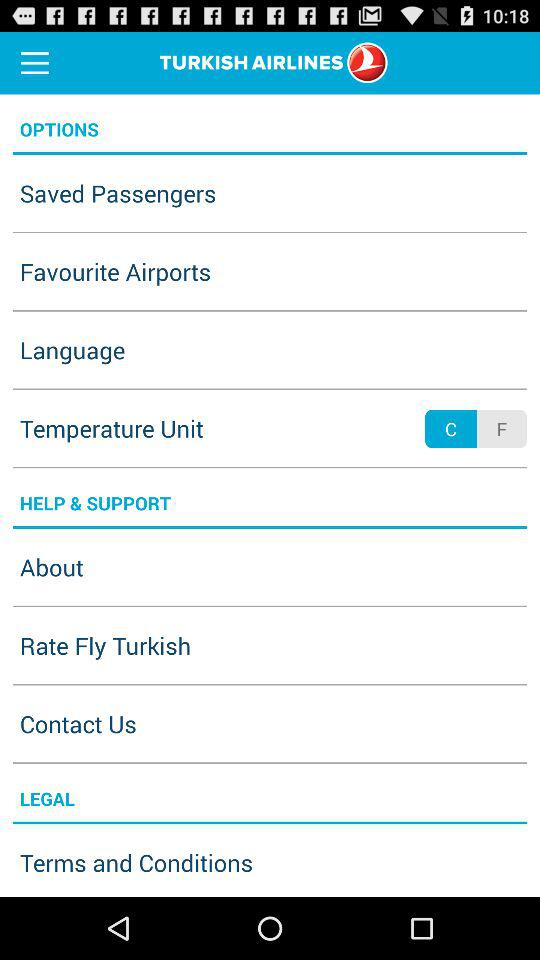What is the name of the application? The name of the application is "TURKISH AIRLINES". 